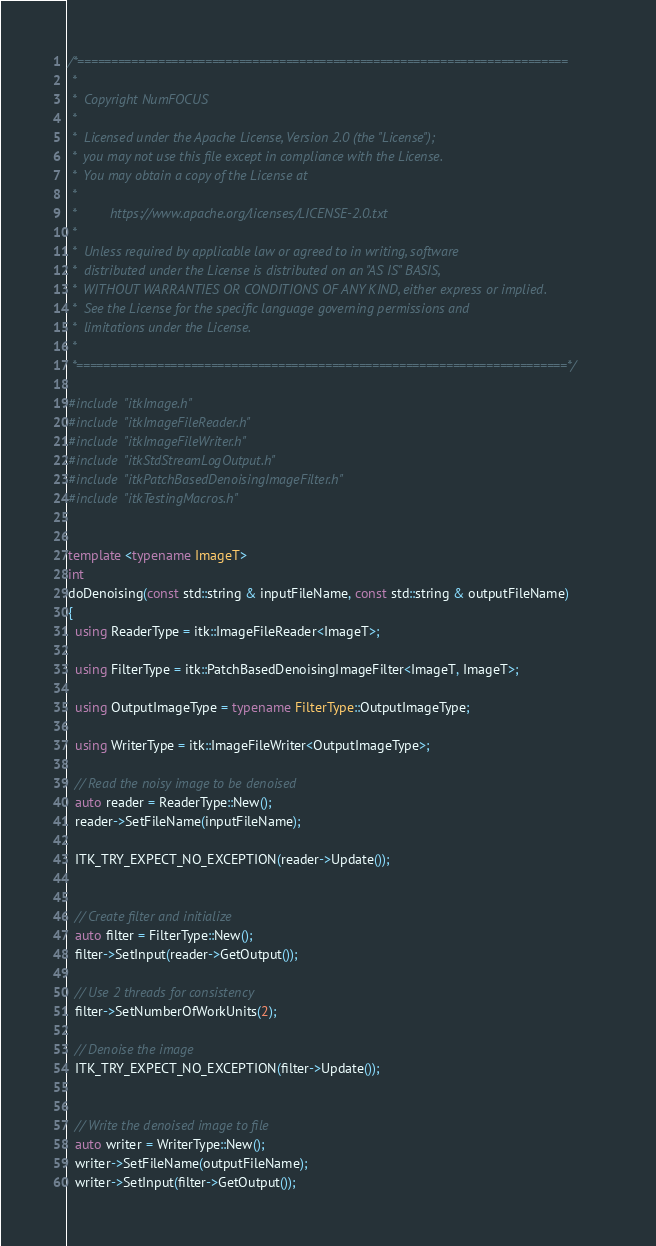<code> <loc_0><loc_0><loc_500><loc_500><_C++_>/*=========================================================================
 *
 *  Copyright NumFOCUS
 *
 *  Licensed under the Apache License, Version 2.0 (the "License");
 *  you may not use this file except in compliance with the License.
 *  You may obtain a copy of the License at
 *
 *         https://www.apache.org/licenses/LICENSE-2.0.txt
 *
 *  Unless required by applicable law or agreed to in writing, software
 *  distributed under the License is distributed on an "AS IS" BASIS,
 *  WITHOUT WARRANTIES OR CONDITIONS OF ANY KIND, either express or implied.
 *  See the License for the specific language governing permissions and
 *  limitations under the License.
 *
 *=========================================================================*/

#include "itkImage.h"
#include "itkImageFileReader.h"
#include "itkImageFileWriter.h"
#include "itkStdStreamLogOutput.h"
#include "itkPatchBasedDenoisingImageFilter.h"
#include "itkTestingMacros.h"


template <typename ImageT>
int
doDenoising(const std::string & inputFileName, const std::string & outputFileName)
{
  using ReaderType = itk::ImageFileReader<ImageT>;

  using FilterType = itk::PatchBasedDenoisingImageFilter<ImageT, ImageT>;

  using OutputImageType = typename FilterType::OutputImageType;

  using WriterType = itk::ImageFileWriter<OutputImageType>;

  // Read the noisy image to be denoised
  auto reader = ReaderType::New();
  reader->SetFileName(inputFileName);

  ITK_TRY_EXPECT_NO_EXCEPTION(reader->Update());


  // Create filter and initialize
  auto filter = FilterType::New();
  filter->SetInput(reader->GetOutput());

  // Use 2 threads for consistency
  filter->SetNumberOfWorkUnits(2);

  // Denoise the image
  ITK_TRY_EXPECT_NO_EXCEPTION(filter->Update());


  // Write the denoised image to file
  auto writer = WriterType::New();
  writer->SetFileName(outputFileName);
  writer->SetInput(filter->GetOutput());
</code> 